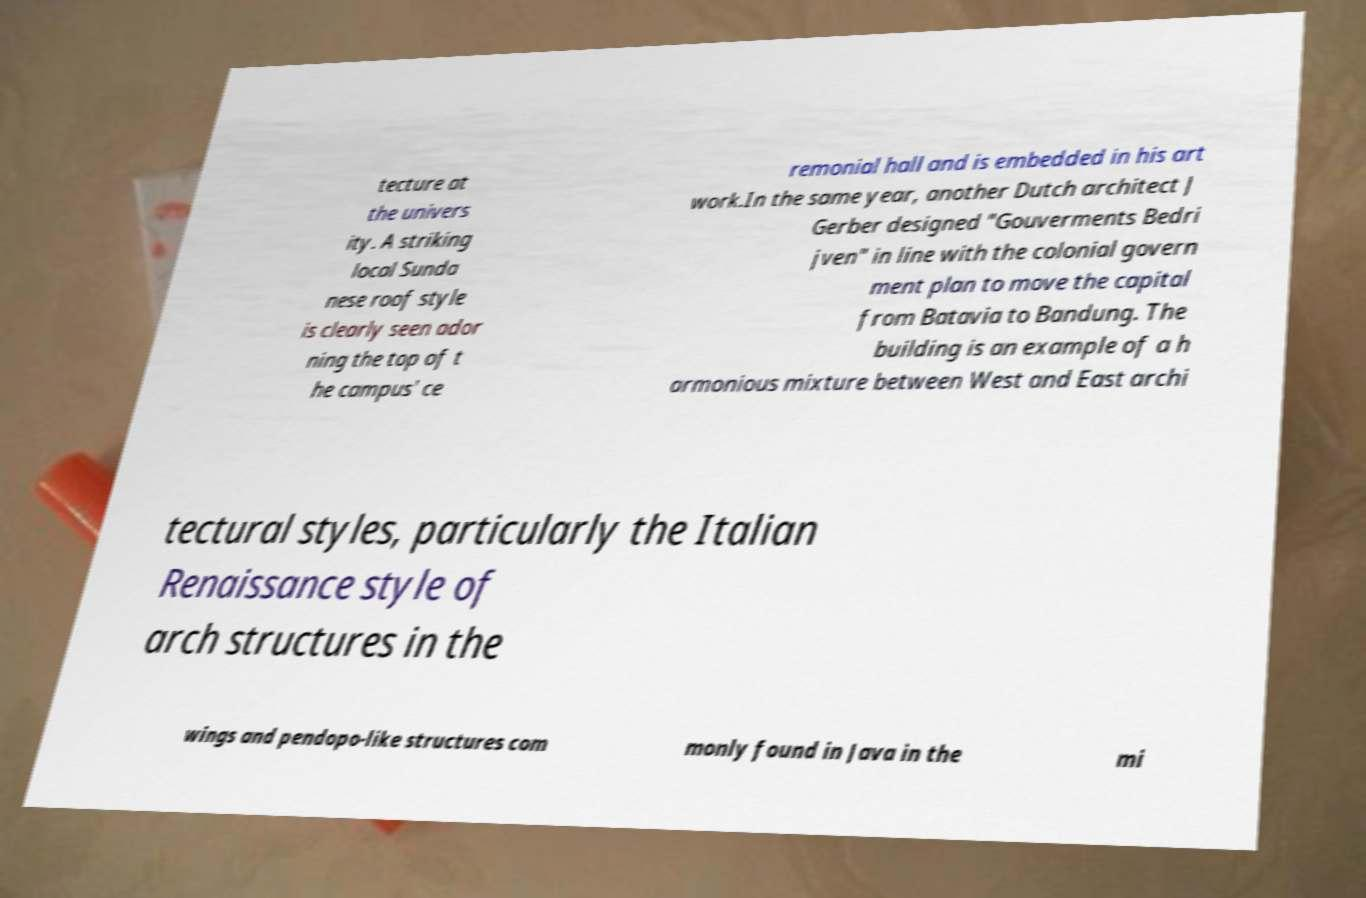I need the written content from this picture converted into text. Can you do that? tecture at the univers ity. A striking local Sunda nese roof style is clearly seen ador ning the top of t he campus' ce remonial hall and is embedded in his art work.In the same year, another Dutch architect J Gerber designed "Gouverments Bedri jven" in line with the colonial govern ment plan to move the capital from Batavia to Bandung. The building is an example of a h armonious mixture between West and East archi tectural styles, particularly the Italian Renaissance style of arch structures in the wings and pendopo-like structures com monly found in Java in the mi 